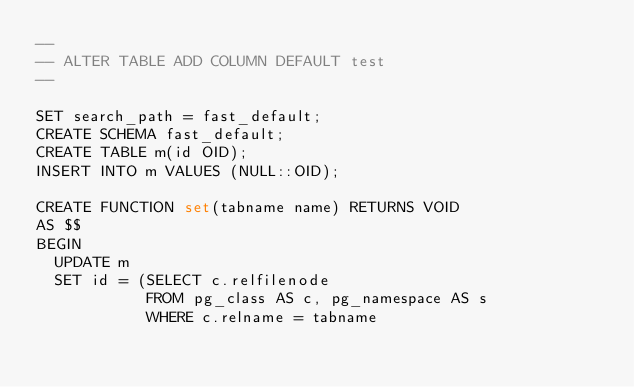Convert code to text. <code><loc_0><loc_0><loc_500><loc_500><_SQL_>--
-- ALTER TABLE ADD COLUMN DEFAULT test
--

SET search_path = fast_default;
CREATE SCHEMA fast_default;
CREATE TABLE m(id OID);
INSERT INTO m VALUES (NULL::OID);

CREATE FUNCTION set(tabname name) RETURNS VOID
AS $$
BEGIN
  UPDATE m
  SET id = (SELECT c.relfilenode
            FROM pg_class AS c, pg_namespace AS s
            WHERE c.relname = tabname</code> 